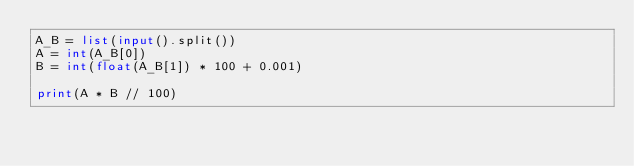<code> <loc_0><loc_0><loc_500><loc_500><_Python_>A_B = list(input().split())
A = int(A_B[0])
B = int(float(A_B[1]) * 100 + 0.001)

print(A * B // 100)

</code> 